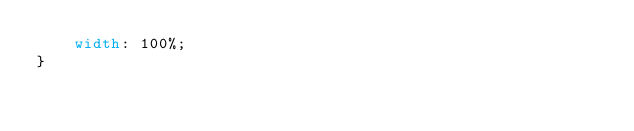<code> <loc_0><loc_0><loc_500><loc_500><_CSS_>    width: 100%;
}</code> 